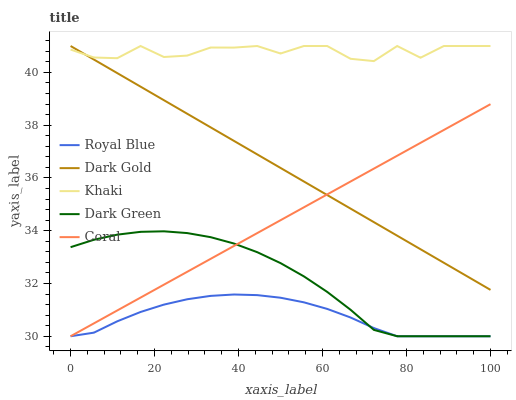Does Royal Blue have the minimum area under the curve?
Answer yes or no. Yes. Does Khaki have the maximum area under the curve?
Answer yes or no. Yes. Does Coral have the minimum area under the curve?
Answer yes or no. No. Does Coral have the maximum area under the curve?
Answer yes or no. No. Is Coral the smoothest?
Answer yes or no. Yes. Is Khaki the roughest?
Answer yes or no. Yes. Is Khaki the smoothest?
Answer yes or no. No. Is Coral the roughest?
Answer yes or no. No. Does Royal Blue have the lowest value?
Answer yes or no. Yes. Does Khaki have the lowest value?
Answer yes or no. No. Does Dark Gold have the highest value?
Answer yes or no. Yes. Does Coral have the highest value?
Answer yes or no. No. Is Coral less than Khaki?
Answer yes or no. Yes. Is Khaki greater than Coral?
Answer yes or no. Yes. Does Royal Blue intersect Dark Green?
Answer yes or no. Yes. Is Royal Blue less than Dark Green?
Answer yes or no. No. Is Royal Blue greater than Dark Green?
Answer yes or no. No. Does Coral intersect Khaki?
Answer yes or no. No. 